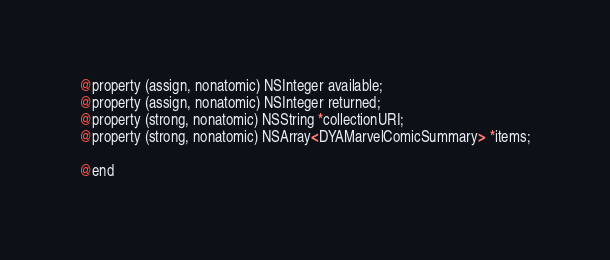<code> <loc_0><loc_0><loc_500><loc_500><_C_>@property (assign, nonatomic) NSInteger available;
@property (assign, nonatomic) NSInteger returned;
@property (strong, nonatomic) NSString *collectionURI;
@property (strong, nonatomic) NSArray<DYAMarvelComicSummary> *items;

@end
</code> 